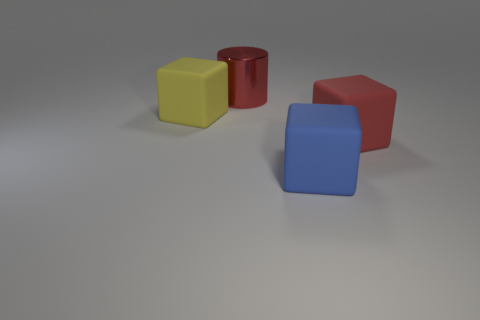Add 3 large red metallic cylinders. How many objects exist? 7 Subtract all cylinders. How many objects are left? 3 Subtract 0 brown spheres. How many objects are left? 4 Subtract all shiny cylinders. Subtract all large red things. How many objects are left? 1 Add 1 red matte cubes. How many red matte cubes are left? 2 Add 2 large cyan metal cubes. How many large cyan metal cubes exist? 2 